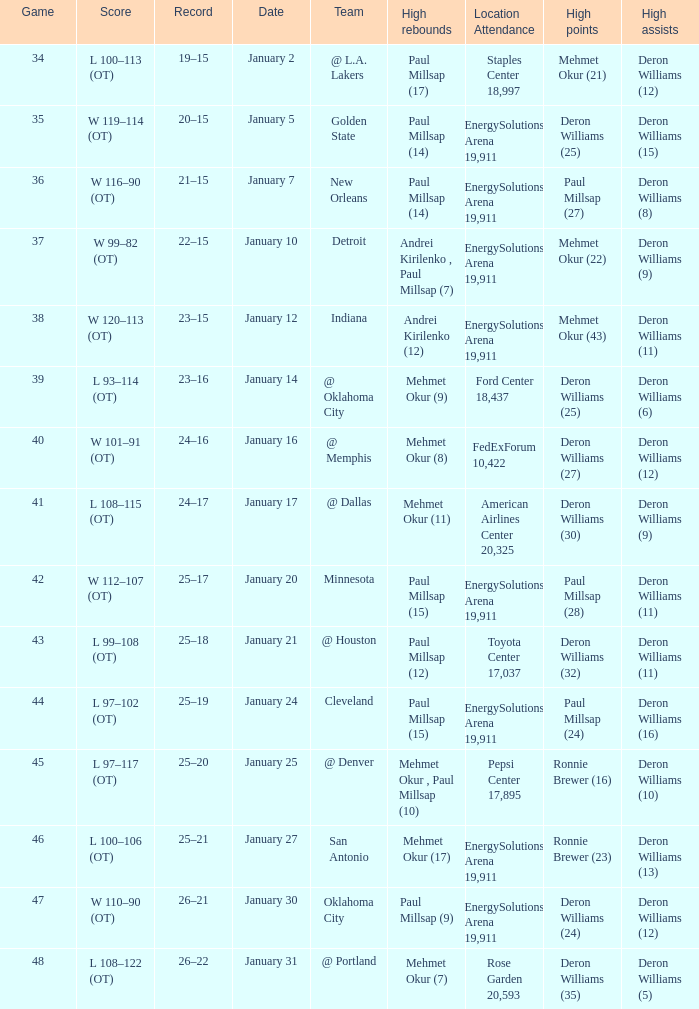Could you parse the entire table? {'header': ['Game', 'Score', 'Record', 'Date', 'Team', 'High rebounds', 'Location Attendance', 'High points', 'High assists'], 'rows': [['34', 'L 100–113 (OT)', '19–15', 'January 2', '@ L.A. Lakers', 'Paul Millsap (17)', 'Staples Center 18,997', 'Mehmet Okur (21)', 'Deron Williams (12)'], ['35', 'W 119–114 (OT)', '20–15', 'January 5', 'Golden State', 'Paul Millsap (14)', 'EnergySolutions Arena 19,911', 'Deron Williams (25)', 'Deron Williams (15)'], ['36', 'W 116–90 (OT)', '21–15', 'January 7', 'New Orleans', 'Paul Millsap (14)', 'EnergySolutions Arena 19,911', 'Paul Millsap (27)', 'Deron Williams (8)'], ['37', 'W 99–82 (OT)', '22–15', 'January 10', 'Detroit', 'Andrei Kirilenko , Paul Millsap (7)', 'EnergySolutions Arena 19,911', 'Mehmet Okur (22)', 'Deron Williams (9)'], ['38', 'W 120–113 (OT)', '23–15', 'January 12', 'Indiana', 'Andrei Kirilenko (12)', 'EnergySolutions Arena 19,911', 'Mehmet Okur (43)', 'Deron Williams (11)'], ['39', 'L 93–114 (OT)', '23–16', 'January 14', '@ Oklahoma City', 'Mehmet Okur (9)', 'Ford Center 18,437', 'Deron Williams (25)', 'Deron Williams (6)'], ['40', 'W 101–91 (OT)', '24–16', 'January 16', '@ Memphis', 'Mehmet Okur (8)', 'FedExForum 10,422', 'Deron Williams (27)', 'Deron Williams (12)'], ['41', 'L 108–115 (OT)', '24–17', 'January 17', '@ Dallas', 'Mehmet Okur (11)', 'American Airlines Center 20,325', 'Deron Williams (30)', 'Deron Williams (9)'], ['42', 'W 112–107 (OT)', '25–17', 'January 20', 'Minnesota', 'Paul Millsap (15)', 'EnergySolutions Arena 19,911', 'Paul Millsap (28)', 'Deron Williams (11)'], ['43', 'L 99–108 (OT)', '25–18', 'January 21', '@ Houston', 'Paul Millsap (12)', 'Toyota Center 17,037', 'Deron Williams (32)', 'Deron Williams (11)'], ['44', 'L 97–102 (OT)', '25–19', 'January 24', 'Cleveland', 'Paul Millsap (15)', 'EnergySolutions Arena 19,911', 'Paul Millsap (24)', 'Deron Williams (16)'], ['45', 'L 97–117 (OT)', '25–20', 'January 25', '@ Denver', 'Mehmet Okur , Paul Millsap (10)', 'Pepsi Center 17,895', 'Ronnie Brewer (16)', 'Deron Williams (10)'], ['46', 'L 100–106 (OT)', '25–21', 'January 27', 'San Antonio', 'Mehmet Okur (17)', 'EnergySolutions Arena 19,911', 'Ronnie Brewer (23)', 'Deron Williams (13)'], ['47', 'W 110–90 (OT)', '26–21', 'January 30', 'Oklahoma City', 'Paul Millsap (9)', 'EnergySolutions Arena 19,911', 'Deron Williams (24)', 'Deron Williams (12)'], ['48', 'L 108–122 (OT)', '26–22', 'January 31', '@ Portland', 'Mehmet Okur (7)', 'Rose Garden 20,593', 'Deron Williams (35)', 'Deron Williams (5)']]} Who had the high rebounds of the game that Deron Williams (5) had the high assists? Mehmet Okur (7). 